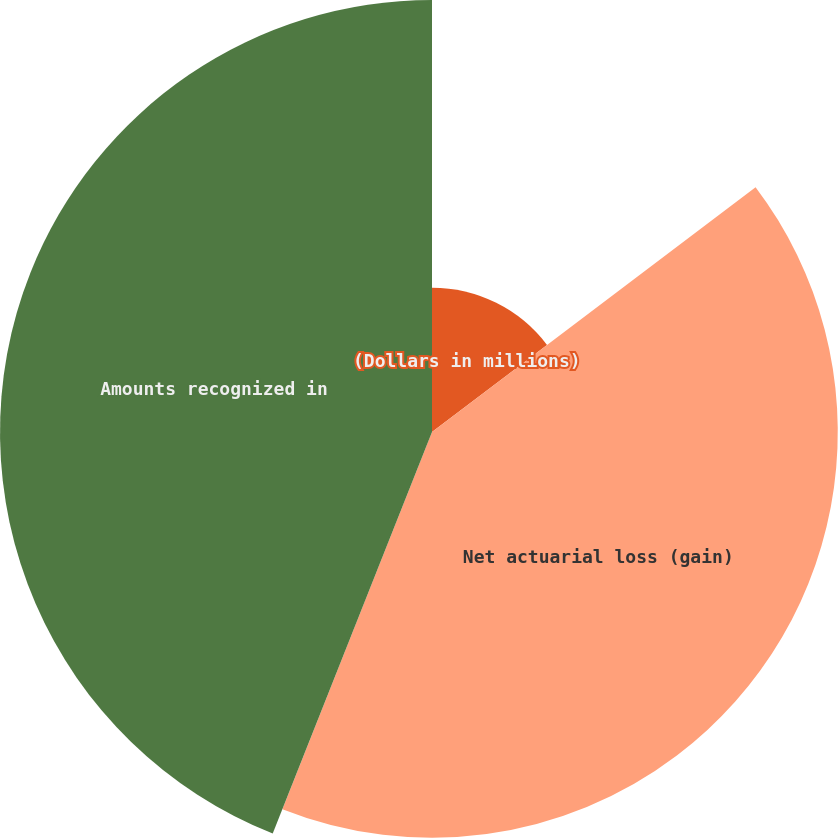Convert chart. <chart><loc_0><loc_0><loc_500><loc_500><pie_chart><fcel>(Dollars in millions)<fcel>Net actuarial loss (gain)<fcel>Amounts recognized in<nl><fcel>14.69%<fcel>41.32%<fcel>43.99%<nl></chart> 